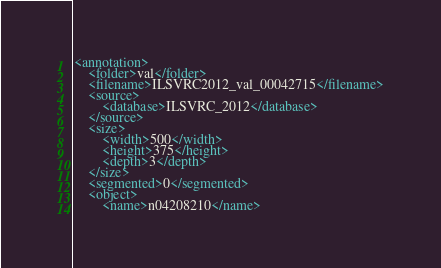Convert code to text. <code><loc_0><loc_0><loc_500><loc_500><_XML_><annotation>
	<folder>val</folder>
	<filename>ILSVRC2012_val_00042715</filename>
	<source>
		<database>ILSVRC_2012</database>
	</source>
	<size>
		<width>500</width>
		<height>375</height>
		<depth>3</depth>
	</size>
	<segmented>0</segmented>
	<object>
		<name>n04208210</name></code> 